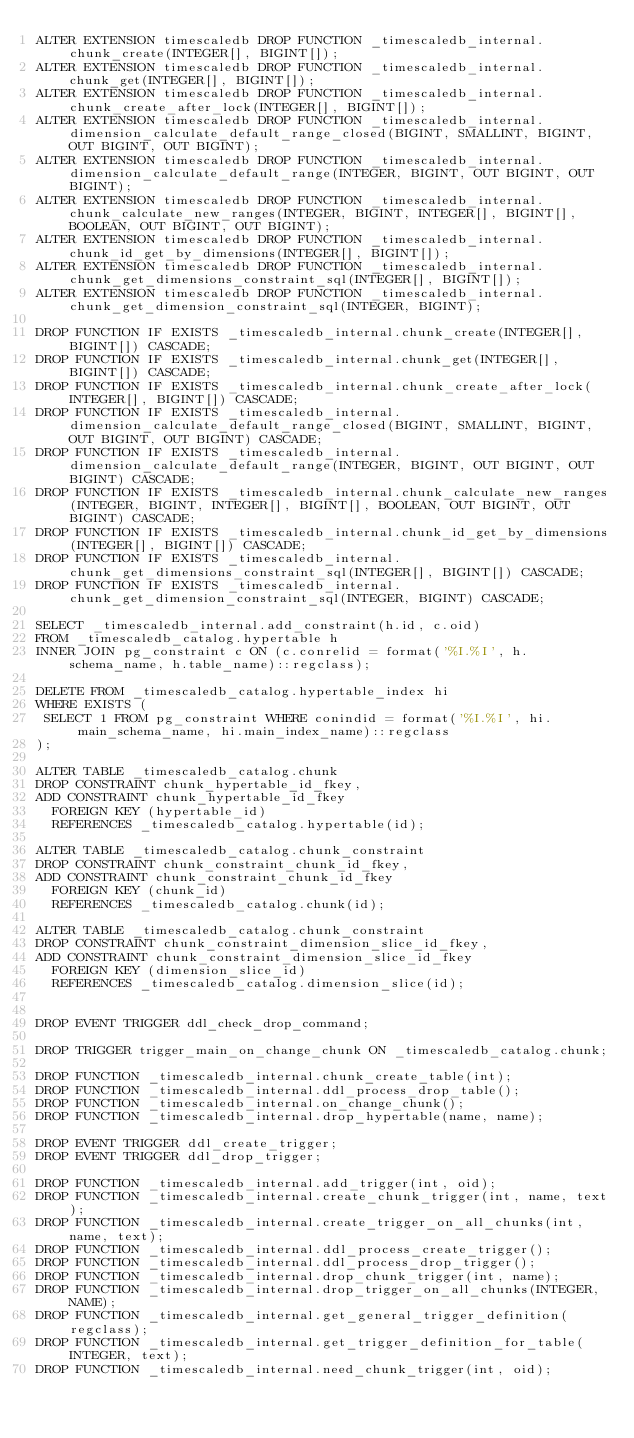Convert code to text. <code><loc_0><loc_0><loc_500><loc_500><_SQL_>ALTER EXTENSION timescaledb DROP FUNCTION _timescaledb_internal.chunk_create(INTEGER[], BIGINT[]);
ALTER EXTENSION timescaledb DROP FUNCTION _timescaledb_internal.chunk_get(INTEGER[], BIGINT[]);
ALTER EXTENSION timescaledb DROP FUNCTION _timescaledb_internal.chunk_create_after_lock(INTEGER[], BIGINT[]);
ALTER EXTENSION timescaledb DROP FUNCTION _timescaledb_internal.dimension_calculate_default_range_closed(BIGINT, SMALLINT, BIGINT, OUT BIGINT, OUT BIGINT);
ALTER EXTENSION timescaledb DROP FUNCTION _timescaledb_internal.dimension_calculate_default_range(INTEGER, BIGINT, OUT BIGINT, OUT BIGINT);
ALTER EXTENSION timescaledb DROP FUNCTION _timescaledb_internal.chunk_calculate_new_ranges(INTEGER, BIGINT, INTEGER[], BIGINT[], BOOLEAN, OUT BIGINT, OUT BIGINT);
ALTER EXTENSION timescaledb DROP FUNCTION _timescaledb_internal.chunk_id_get_by_dimensions(INTEGER[], BIGINT[]);
ALTER EXTENSION timescaledb DROP FUNCTION _timescaledb_internal.chunk_get_dimensions_constraint_sql(INTEGER[], BIGINT[]);
ALTER EXTENSION timescaledb DROP FUNCTION _timescaledb_internal.chunk_get_dimension_constraint_sql(INTEGER, BIGINT);

DROP FUNCTION IF EXISTS _timescaledb_internal.chunk_create(INTEGER[], BIGINT[]) CASCADE;
DROP FUNCTION IF EXISTS _timescaledb_internal.chunk_get(INTEGER[], BIGINT[]) CASCADE;
DROP FUNCTION IF EXISTS _timescaledb_internal.chunk_create_after_lock(INTEGER[], BIGINT[]) CASCADE;
DROP FUNCTION IF EXISTS _timescaledb_internal.dimension_calculate_default_range_closed(BIGINT, SMALLINT, BIGINT, OUT BIGINT, OUT BIGINT) CASCADE;
DROP FUNCTION IF EXISTS _timescaledb_internal.dimension_calculate_default_range(INTEGER, BIGINT, OUT BIGINT, OUT BIGINT) CASCADE;
DROP FUNCTION IF EXISTS _timescaledb_internal.chunk_calculate_new_ranges(INTEGER, BIGINT, INTEGER[], BIGINT[], BOOLEAN, OUT BIGINT, OUT BIGINT) CASCADE;
DROP FUNCTION IF EXISTS _timescaledb_internal.chunk_id_get_by_dimensions(INTEGER[], BIGINT[]) CASCADE;
DROP FUNCTION IF EXISTS _timescaledb_internal.chunk_get_dimensions_constraint_sql(INTEGER[], BIGINT[]) CASCADE;
DROP FUNCTION IF EXISTS _timescaledb_internal.chunk_get_dimension_constraint_sql(INTEGER, BIGINT) CASCADE;

SELECT _timescaledb_internal.add_constraint(h.id, c.oid)
FROM _timescaledb_catalog.hypertable h
INNER JOIN pg_constraint c ON (c.conrelid = format('%I.%I', h.schema_name, h.table_name)::regclass);

DELETE FROM _timescaledb_catalog.hypertable_index hi
WHERE EXISTS (
 SELECT 1 FROM pg_constraint WHERE conindid = format('%I.%I', hi.main_schema_name, hi.main_index_name)::regclass
);

ALTER TABLE _timescaledb_catalog.chunk
DROP CONSTRAINT chunk_hypertable_id_fkey,
ADD CONSTRAINT chunk_hypertable_id_fkey
  FOREIGN KEY (hypertable_id) 
  REFERENCES _timescaledb_catalog.hypertable(id);

ALTER TABLE _timescaledb_catalog.chunk_constraint
DROP CONSTRAINT chunk_constraint_chunk_id_fkey,
ADD CONSTRAINT chunk_constraint_chunk_id_fkey
  FOREIGN KEY (chunk_id) 
  REFERENCES _timescaledb_catalog.chunk(id);

ALTER TABLE _timescaledb_catalog.chunk_constraint
DROP CONSTRAINT chunk_constraint_dimension_slice_id_fkey,
ADD CONSTRAINT chunk_constraint_dimension_slice_id_fkey
  FOREIGN KEY (dimension_slice_id) 
  REFERENCES _timescaledb_catalog.dimension_slice(id);


DROP EVENT TRIGGER ddl_check_drop_command;

DROP TRIGGER trigger_main_on_change_chunk ON _timescaledb_catalog.chunk;

DROP FUNCTION _timescaledb_internal.chunk_create_table(int);
DROP FUNCTION _timescaledb_internal.ddl_process_drop_table();
DROP FUNCTION _timescaledb_internal.on_change_chunk();
DROP FUNCTION _timescaledb_internal.drop_hypertable(name, name);

DROP EVENT TRIGGER ddl_create_trigger;
DROP EVENT TRIGGER ddl_drop_trigger;

DROP FUNCTION _timescaledb_internal.add_trigger(int, oid);
DROP FUNCTION _timescaledb_internal.create_chunk_trigger(int, name, text);
DROP FUNCTION _timescaledb_internal.create_trigger_on_all_chunks(int, name, text);
DROP FUNCTION _timescaledb_internal.ddl_process_create_trigger();
DROP FUNCTION _timescaledb_internal.ddl_process_drop_trigger();
DROP FUNCTION _timescaledb_internal.drop_chunk_trigger(int, name);
DROP FUNCTION _timescaledb_internal.drop_trigger_on_all_chunks(INTEGER, NAME);
DROP FUNCTION _timescaledb_internal.get_general_trigger_definition(regclass);
DROP FUNCTION _timescaledb_internal.get_trigger_definition_for_table(INTEGER, text);
DROP FUNCTION _timescaledb_internal.need_chunk_trigger(int, oid);
</code> 